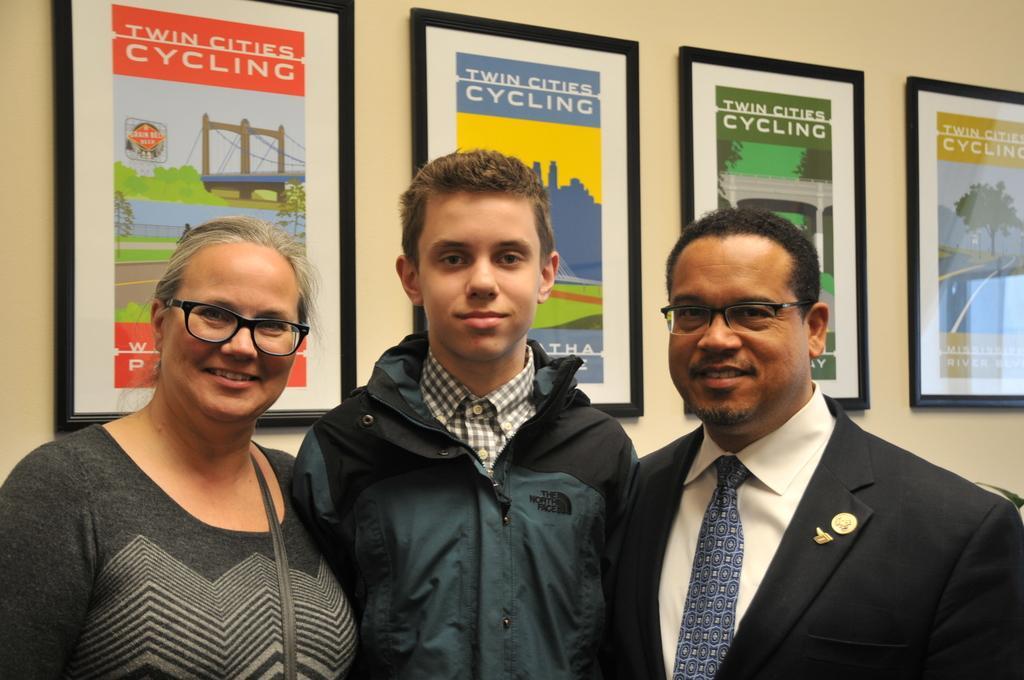In one or two sentences, can you explain what this image depicts? In this image there are three persons standing in the middle. In the background there is a wall to which there are frames. There is a woman on the left side. 